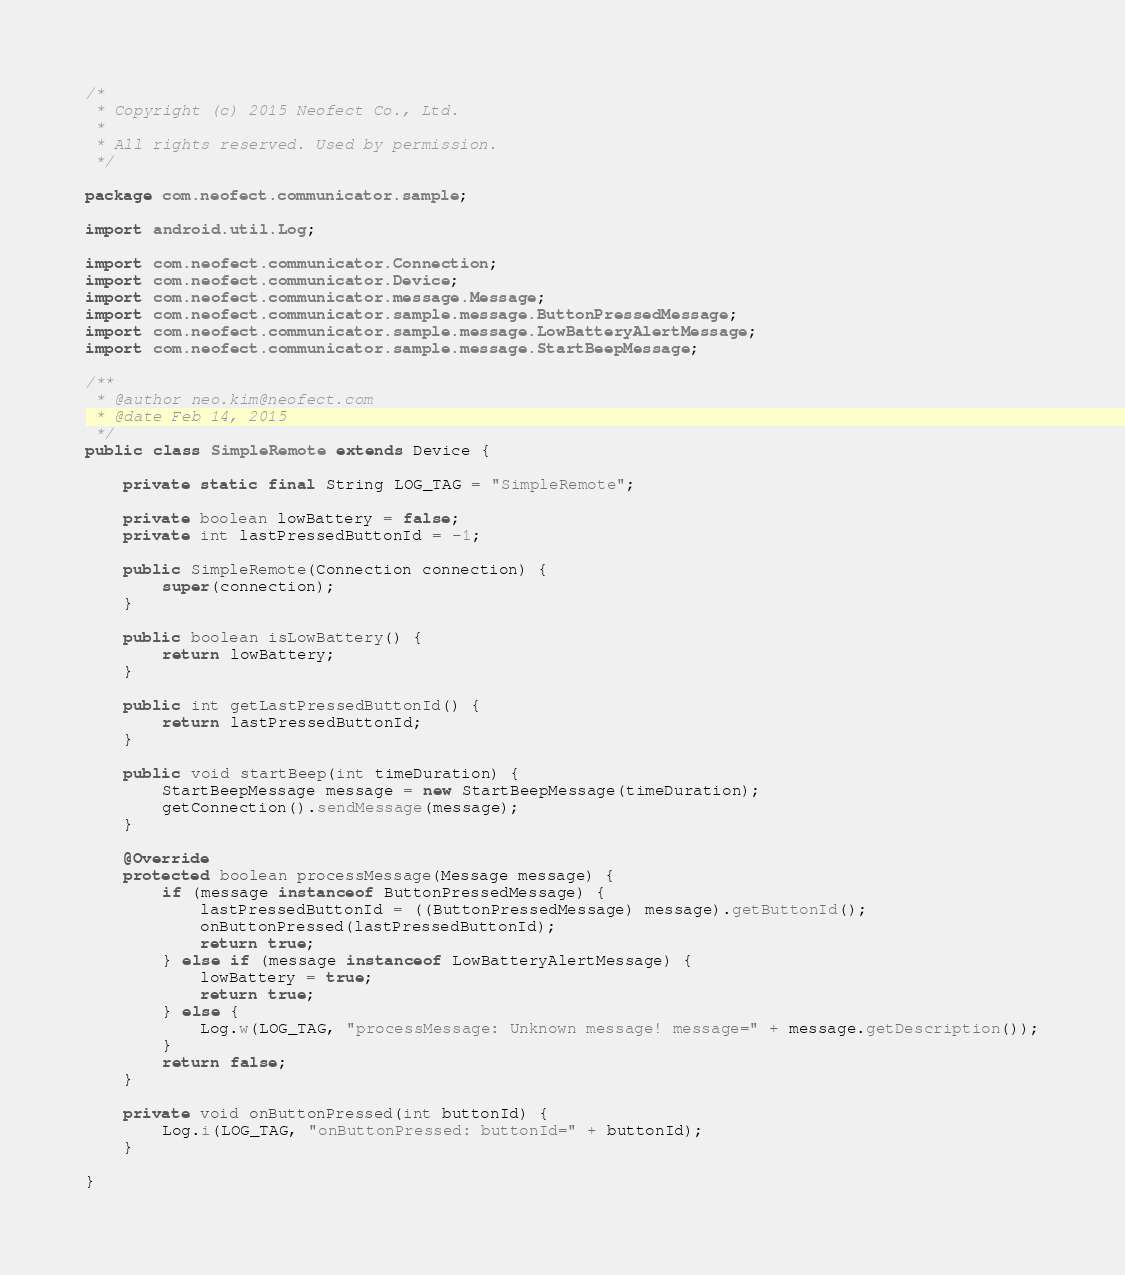Convert code to text. <code><loc_0><loc_0><loc_500><loc_500><_Java_>/*
 * Copyright (c) 2015 Neofect Co., Ltd.
 * 
 * All rights reserved. Used by permission.
 */

package com.neofect.communicator.sample;

import android.util.Log;

import com.neofect.communicator.Connection;
import com.neofect.communicator.Device;
import com.neofect.communicator.message.Message;
import com.neofect.communicator.sample.message.ButtonPressedMessage;
import com.neofect.communicator.sample.message.LowBatteryAlertMessage;
import com.neofect.communicator.sample.message.StartBeepMessage;

/**
 * @author neo.kim@neofect.com
 * @date Feb 14, 2015
 */
public class SimpleRemote extends Device {

	private static final String LOG_TAG = "SimpleRemote";

	private boolean lowBattery = false;
	private int lastPressedButtonId = -1;

	public SimpleRemote(Connection connection) {
		super(connection);
	}

	public boolean isLowBattery() {
		return lowBattery;
	}

	public int getLastPressedButtonId() {
		return lastPressedButtonId;
	}

	public void startBeep(int timeDuration) {
		StartBeepMessage message = new StartBeepMessage(timeDuration);
		getConnection().sendMessage(message);
	}
	
	@Override
	protected boolean processMessage(Message message) {
		if (message instanceof ButtonPressedMessage) {
			lastPressedButtonId = ((ButtonPressedMessage) message).getButtonId();
			onButtonPressed(lastPressedButtonId);
			return true;
		} else if (message instanceof LowBatteryAlertMessage) {
			lowBattery = true;
			return true;
		} else {
			Log.w(LOG_TAG, "processMessage: Unknown message! message=" + message.getDescription());
		}
		return false;
	}

	private void onButtonPressed(int buttonId) {
		Log.i(LOG_TAG, "onButtonPressed: buttonId=" + buttonId);
	}

}
</code> 